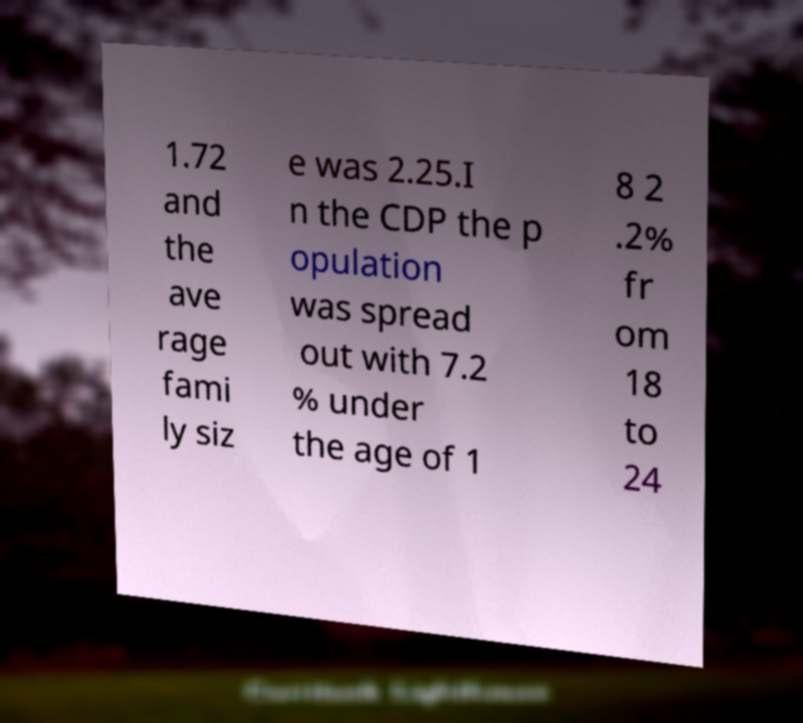What messages or text are displayed in this image? I need them in a readable, typed format. 1.72 and the ave rage fami ly siz e was 2.25.I n the CDP the p opulation was spread out with 7.2 % under the age of 1 8 2 .2% fr om 18 to 24 